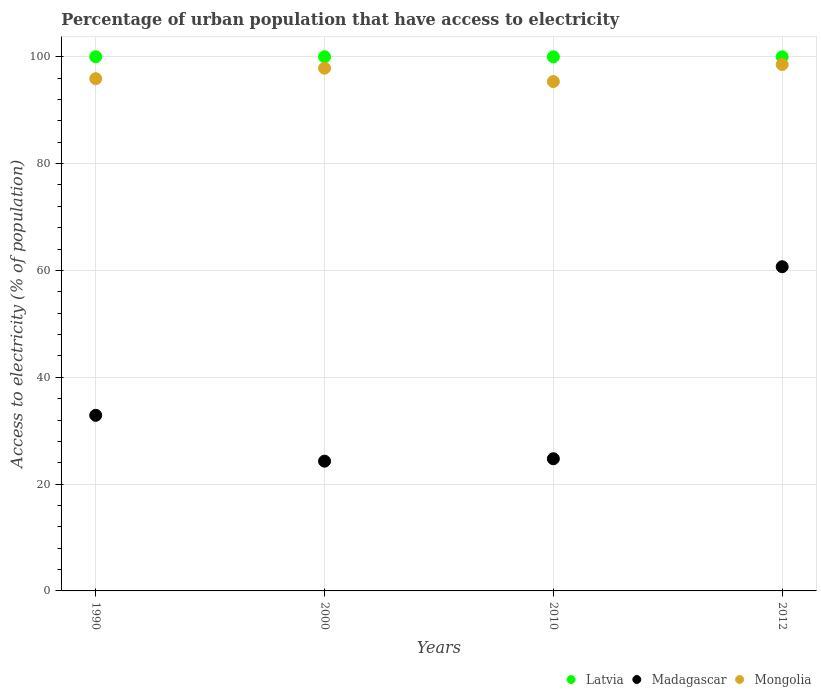What is the percentage of urban population that have access to electricity in Mongolia in 2010?
Provide a short and direct response. 95.37. Across all years, what is the maximum percentage of urban population that have access to electricity in Madagascar?
Keep it short and to the point. 60.7. Across all years, what is the minimum percentage of urban population that have access to electricity in Mongolia?
Ensure brevity in your answer.  95.37. What is the total percentage of urban population that have access to electricity in Latvia in the graph?
Provide a succinct answer. 400. What is the difference between the percentage of urban population that have access to electricity in Latvia in 1990 and that in 2000?
Offer a terse response. 0. What is the difference between the percentage of urban population that have access to electricity in Madagascar in 2000 and the percentage of urban population that have access to electricity in Mongolia in 2010?
Make the answer very short. -71.08. What is the average percentage of urban population that have access to electricity in Madagascar per year?
Keep it short and to the point. 35.65. In the year 2012, what is the difference between the percentage of urban population that have access to electricity in Latvia and percentage of urban population that have access to electricity in Mongolia?
Offer a terse response. 1.44. Is the percentage of urban population that have access to electricity in Madagascar in 1990 less than that in 2010?
Give a very brief answer. No. Is the difference between the percentage of urban population that have access to electricity in Latvia in 2000 and 2012 greater than the difference between the percentage of urban population that have access to electricity in Mongolia in 2000 and 2012?
Your response must be concise. Yes. What is the difference between the highest and the second highest percentage of urban population that have access to electricity in Madagascar?
Keep it short and to the point. 27.82. What is the difference between the highest and the lowest percentage of urban population that have access to electricity in Mongolia?
Offer a very short reply. 3.19. Is the sum of the percentage of urban population that have access to electricity in Madagascar in 2010 and 2012 greater than the maximum percentage of urban population that have access to electricity in Latvia across all years?
Provide a short and direct response. No. Is it the case that in every year, the sum of the percentage of urban population that have access to electricity in Latvia and percentage of urban population that have access to electricity in Mongolia  is greater than the percentage of urban population that have access to electricity in Madagascar?
Keep it short and to the point. Yes. Does the percentage of urban population that have access to electricity in Mongolia monotonically increase over the years?
Your response must be concise. No. Is the percentage of urban population that have access to electricity in Madagascar strictly greater than the percentage of urban population that have access to electricity in Mongolia over the years?
Offer a very short reply. No. What is the difference between two consecutive major ticks on the Y-axis?
Keep it short and to the point. 20. Does the graph contain grids?
Ensure brevity in your answer.  Yes. How many legend labels are there?
Ensure brevity in your answer.  3. How are the legend labels stacked?
Offer a very short reply. Horizontal. What is the title of the graph?
Ensure brevity in your answer.  Percentage of urban population that have access to electricity. Does "Macedonia" appear as one of the legend labels in the graph?
Offer a very short reply. No. What is the label or title of the X-axis?
Your response must be concise. Years. What is the label or title of the Y-axis?
Give a very brief answer. Access to electricity (% of population). What is the Access to electricity (% of population) of Madagascar in 1990?
Your answer should be very brief. 32.88. What is the Access to electricity (% of population) of Mongolia in 1990?
Keep it short and to the point. 95.9. What is the Access to electricity (% of population) in Madagascar in 2000?
Provide a short and direct response. 24.29. What is the Access to electricity (% of population) of Mongolia in 2000?
Offer a very short reply. 97.87. What is the Access to electricity (% of population) of Latvia in 2010?
Provide a succinct answer. 100. What is the Access to electricity (% of population) in Madagascar in 2010?
Give a very brief answer. 24.75. What is the Access to electricity (% of population) in Mongolia in 2010?
Keep it short and to the point. 95.37. What is the Access to electricity (% of population) in Madagascar in 2012?
Provide a succinct answer. 60.7. What is the Access to electricity (% of population) of Mongolia in 2012?
Your answer should be compact. 98.56. Across all years, what is the maximum Access to electricity (% of population) of Latvia?
Your answer should be very brief. 100. Across all years, what is the maximum Access to electricity (% of population) of Madagascar?
Provide a succinct answer. 60.7. Across all years, what is the maximum Access to electricity (% of population) of Mongolia?
Your response must be concise. 98.56. Across all years, what is the minimum Access to electricity (% of population) of Latvia?
Offer a terse response. 100. Across all years, what is the minimum Access to electricity (% of population) of Madagascar?
Offer a very short reply. 24.29. Across all years, what is the minimum Access to electricity (% of population) of Mongolia?
Make the answer very short. 95.37. What is the total Access to electricity (% of population) in Madagascar in the graph?
Offer a very short reply. 142.61. What is the total Access to electricity (% of population) of Mongolia in the graph?
Your answer should be very brief. 387.7. What is the difference between the Access to electricity (% of population) in Madagascar in 1990 and that in 2000?
Ensure brevity in your answer.  8.59. What is the difference between the Access to electricity (% of population) in Mongolia in 1990 and that in 2000?
Provide a short and direct response. -1.96. What is the difference between the Access to electricity (% of population) in Latvia in 1990 and that in 2010?
Your response must be concise. 0. What is the difference between the Access to electricity (% of population) in Madagascar in 1990 and that in 2010?
Make the answer very short. 8.13. What is the difference between the Access to electricity (% of population) of Mongolia in 1990 and that in 2010?
Offer a very short reply. 0.54. What is the difference between the Access to electricity (% of population) in Madagascar in 1990 and that in 2012?
Your answer should be very brief. -27.82. What is the difference between the Access to electricity (% of population) in Mongolia in 1990 and that in 2012?
Provide a succinct answer. -2.66. What is the difference between the Access to electricity (% of population) of Madagascar in 2000 and that in 2010?
Your response must be concise. -0.45. What is the difference between the Access to electricity (% of population) in Mongolia in 2000 and that in 2010?
Your answer should be very brief. 2.5. What is the difference between the Access to electricity (% of population) in Madagascar in 2000 and that in 2012?
Your answer should be compact. -36.41. What is the difference between the Access to electricity (% of population) in Mongolia in 2000 and that in 2012?
Your answer should be compact. -0.69. What is the difference between the Access to electricity (% of population) of Latvia in 2010 and that in 2012?
Provide a short and direct response. 0. What is the difference between the Access to electricity (% of population) in Madagascar in 2010 and that in 2012?
Ensure brevity in your answer.  -35.95. What is the difference between the Access to electricity (% of population) in Mongolia in 2010 and that in 2012?
Ensure brevity in your answer.  -3.19. What is the difference between the Access to electricity (% of population) of Latvia in 1990 and the Access to electricity (% of population) of Madagascar in 2000?
Your response must be concise. 75.71. What is the difference between the Access to electricity (% of population) in Latvia in 1990 and the Access to electricity (% of population) in Mongolia in 2000?
Ensure brevity in your answer.  2.13. What is the difference between the Access to electricity (% of population) of Madagascar in 1990 and the Access to electricity (% of population) of Mongolia in 2000?
Offer a terse response. -64.99. What is the difference between the Access to electricity (% of population) in Latvia in 1990 and the Access to electricity (% of population) in Madagascar in 2010?
Give a very brief answer. 75.25. What is the difference between the Access to electricity (% of population) in Latvia in 1990 and the Access to electricity (% of population) in Mongolia in 2010?
Make the answer very short. 4.63. What is the difference between the Access to electricity (% of population) in Madagascar in 1990 and the Access to electricity (% of population) in Mongolia in 2010?
Keep it short and to the point. -62.49. What is the difference between the Access to electricity (% of population) in Latvia in 1990 and the Access to electricity (% of population) in Madagascar in 2012?
Keep it short and to the point. 39.3. What is the difference between the Access to electricity (% of population) of Latvia in 1990 and the Access to electricity (% of population) of Mongolia in 2012?
Ensure brevity in your answer.  1.44. What is the difference between the Access to electricity (% of population) of Madagascar in 1990 and the Access to electricity (% of population) of Mongolia in 2012?
Ensure brevity in your answer.  -65.68. What is the difference between the Access to electricity (% of population) of Latvia in 2000 and the Access to electricity (% of population) of Madagascar in 2010?
Make the answer very short. 75.25. What is the difference between the Access to electricity (% of population) of Latvia in 2000 and the Access to electricity (% of population) of Mongolia in 2010?
Keep it short and to the point. 4.63. What is the difference between the Access to electricity (% of population) of Madagascar in 2000 and the Access to electricity (% of population) of Mongolia in 2010?
Ensure brevity in your answer.  -71.08. What is the difference between the Access to electricity (% of population) in Latvia in 2000 and the Access to electricity (% of population) in Madagascar in 2012?
Your answer should be compact. 39.3. What is the difference between the Access to electricity (% of population) of Latvia in 2000 and the Access to electricity (% of population) of Mongolia in 2012?
Offer a very short reply. 1.44. What is the difference between the Access to electricity (% of population) of Madagascar in 2000 and the Access to electricity (% of population) of Mongolia in 2012?
Your answer should be compact. -74.27. What is the difference between the Access to electricity (% of population) of Latvia in 2010 and the Access to electricity (% of population) of Madagascar in 2012?
Your answer should be compact. 39.3. What is the difference between the Access to electricity (% of population) in Latvia in 2010 and the Access to electricity (% of population) in Mongolia in 2012?
Offer a terse response. 1.44. What is the difference between the Access to electricity (% of population) of Madagascar in 2010 and the Access to electricity (% of population) of Mongolia in 2012?
Offer a very short reply. -73.82. What is the average Access to electricity (% of population) of Latvia per year?
Your answer should be compact. 100. What is the average Access to electricity (% of population) in Madagascar per year?
Make the answer very short. 35.65. What is the average Access to electricity (% of population) of Mongolia per year?
Your response must be concise. 96.93. In the year 1990, what is the difference between the Access to electricity (% of population) of Latvia and Access to electricity (% of population) of Madagascar?
Your response must be concise. 67.12. In the year 1990, what is the difference between the Access to electricity (% of population) in Latvia and Access to electricity (% of population) in Mongolia?
Your answer should be very brief. 4.1. In the year 1990, what is the difference between the Access to electricity (% of population) of Madagascar and Access to electricity (% of population) of Mongolia?
Provide a succinct answer. -63.03. In the year 2000, what is the difference between the Access to electricity (% of population) of Latvia and Access to electricity (% of population) of Madagascar?
Your response must be concise. 75.71. In the year 2000, what is the difference between the Access to electricity (% of population) of Latvia and Access to electricity (% of population) of Mongolia?
Offer a very short reply. 2.13. In the year 2000, what is the difference between the Access to electricity (% of population) of Madagascar and Access to electricity (% of population) of Mongolia?
Provide a succinct answer. -73.58. In the year 2010, what is the difference between the Access to electricity (% of population) of Latvia and Access to electricity (% of population) of Madagascar?
Offer a terse response. 75.25. In the year 2010, what is the difference between the Access to electricity (% of population) in Latvia and Access to electricity (% of population) in Mongolia?
Provide a short and direct response. 4.63. In the year 2010, what is the difference between the Access to electricity (% of population) in Madagascar and Access to electricity (% of population) in Mongolia?
Your answer should be very brief. -70.62. In the year 2012, what is the difference between the Access to electricity (% of population) in Latvia and Access to electricity (% of population) in Madagascar?
Give a very brief answer. 39.3. In the year 2012, what is the difference between the Access to electricity (% of population) in Latvia and Access to electricity (% of population) in Mongolia?
Ensure brevity in your answer.  1.44. In the year 2012, what is the difference between the Access to electricity (% of population) in Madagascar and Access to electricity (% of population) in Mongolia?
Offer a terse response. -37.86. What is the ratio of the Access to electricity (% of population) in Madagascar in 1990 to that in 2000?
Your response must be concise. 1.35. What is the ratio of the Access to electricity (% of population) in Mongolia in 1990 to that in 2000?
Your answer should be compact. 0.98. What is the ratio of the Access to electricity (% of population) of Latvia in 1990 to that in 2010?
Make the answer very short. 1. What is the ratio of the Access to electricity (% of population) of Madagascar in 1990 to that in 2010?
Your response must be concise. 1.33. What is the ratio of the Access to electricity (% of population) of Mongolia in 1990 to that in 2010?
Keep it short and to the point. 1.01. What is the ratio of the Access to electricity (% of population) of Latvia in 1990 to that in 2012?
Offer a very short reply. 1. What is the ratio of the Access to electricity (% of population) of Madagascar in 1990 to that in 2012?
Provide a short and direct response. 0.54. What is the ratio of the Access to electricity (% of population) of Madagascar in 2000 to that in 2010?
Make the answer very short. 0.98. What is the ratio of the Access to electricity (% of population) in Mongolia in 2000 to that in 2010?
Give a very brief answer. 1.03. What is the ratio of the Access to electricity (% of population) in Madagascar in 2000 to that in 2012?
Your answer should be very brief. 0.4. What is the ratio of the Access to electricity (% of population) of Mongolia in 2000 to that in 2012?
Offer a very short reply. 0.99. What is the ratio of the Access to electricity (% of population) in Madagascar in 2010 to that in 2012?
Offer a very short reply. 0.41. What is the ratio of the Access to electricity (% of population) of Mongolia in 2010 to that in 2012?
Your response must be concise. 0.97. What is the difference between the highest and the second highest Access to electricity (% of population) in Madagascar?
Keep it short and to the point. 27.82. What is the difference between the highest and the second highest Access to electricity (% of population) in Mongolia?
Keep it short and to the point. 0.69. What is the difference between the highest and the lowest Access to electricity (% of population) of Latvia?
Your response must be concise. 0. What is the difference between the highest and the lowest Access to electricity (% of population) of Madagascar?
Your response must be concise. 36.41. What is the difference between the highest and the lowest Access to electricity (% of population) of Mongolia?
Your answer should be compact. 3.19. 